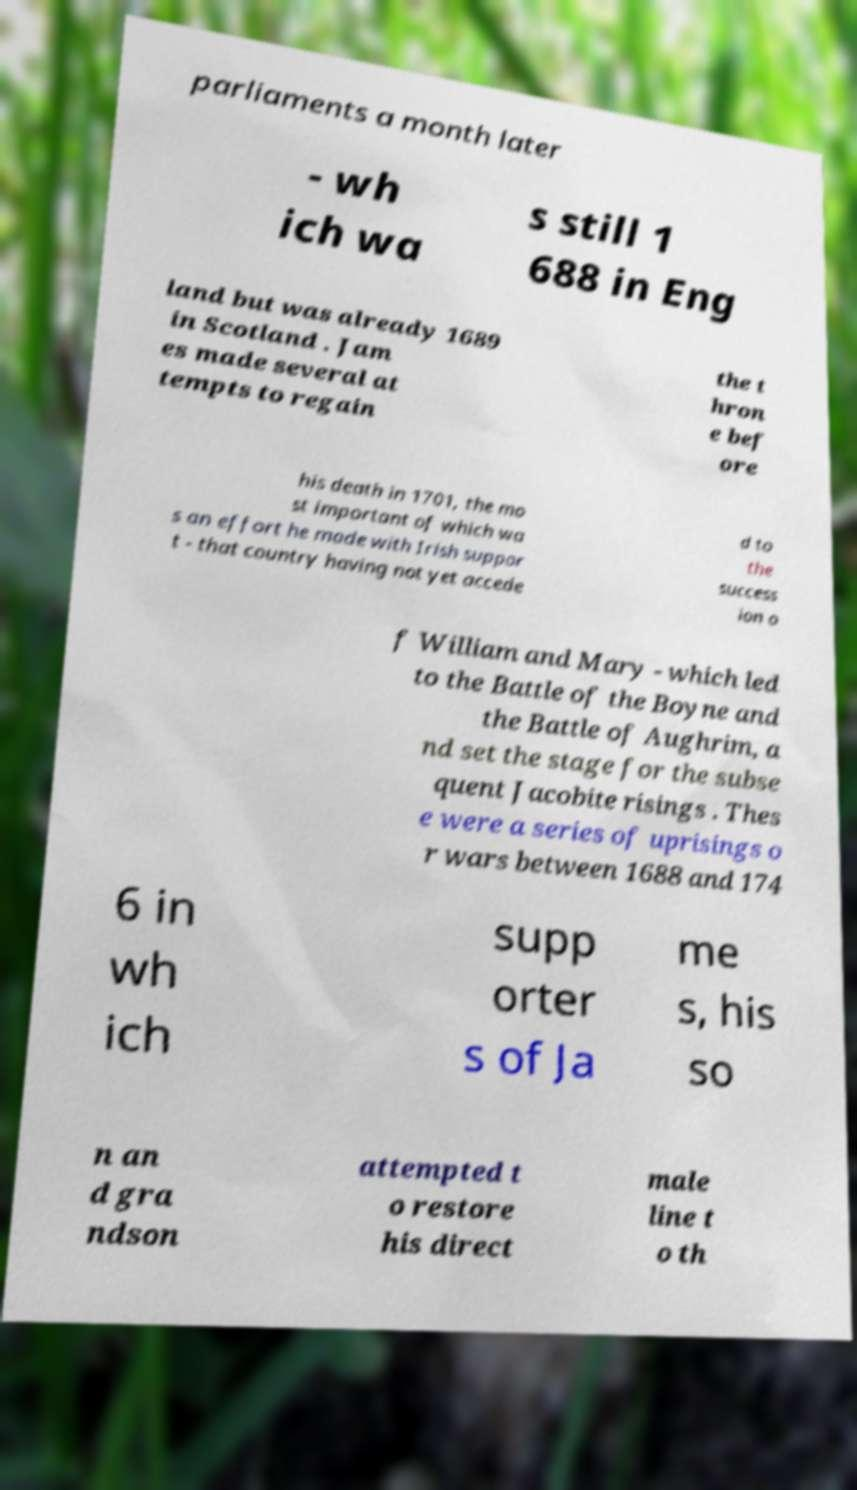What messages or text are displayed in this image? I need them in a readable, typed format. parliaments a month later - wh ich wa s still 1 688 in Eng land but was already 1689 in Scotland . Jam es made several at tempts to regain the t hron e bef ore his death in 1701, the mo st important of which wa s an effort he made with Irish suppor t - that country having not yet accede d to the success ion o f William and Mary - which led to the Battle of the Boyne and the Battle of Aughrim, a nd set the stage for the subse quent Jacobite risings . Thes e were a series of uprisings o r wars between 1688 and 174 6 in wh ich supp orter s of Ja me s, his so n an d gra ndson attempted t o restore his direct male line t o th 